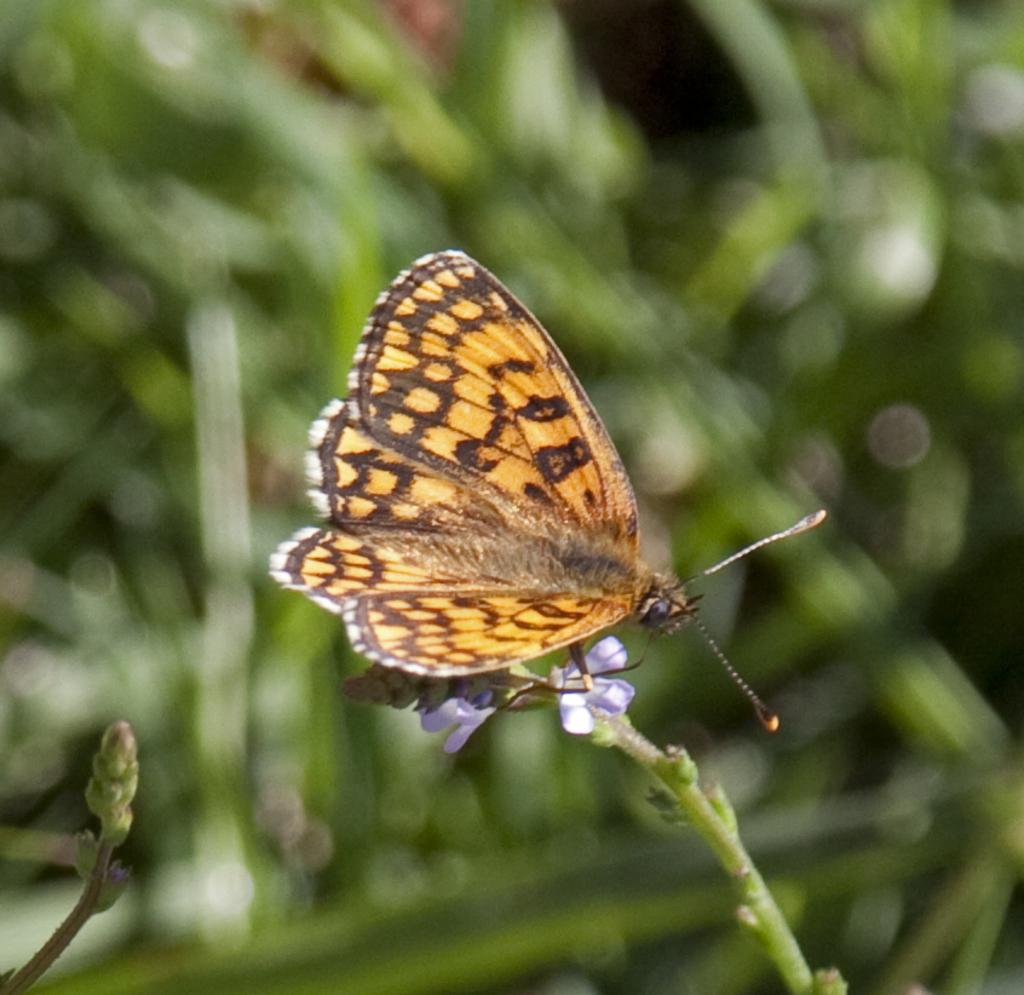What is the main subject of the image? There is a butterfly in the center of the image. What is the butterfly resting on? The butterfly is on small flowers. What can be seen in the background of the image? There is greenery in the background of the image. What hearing theory is being demonstrated by the butterfly in the image? There is no hearing theory being demonstrated in the image, as it features a butterfly on small flowers with greenery in the background. 